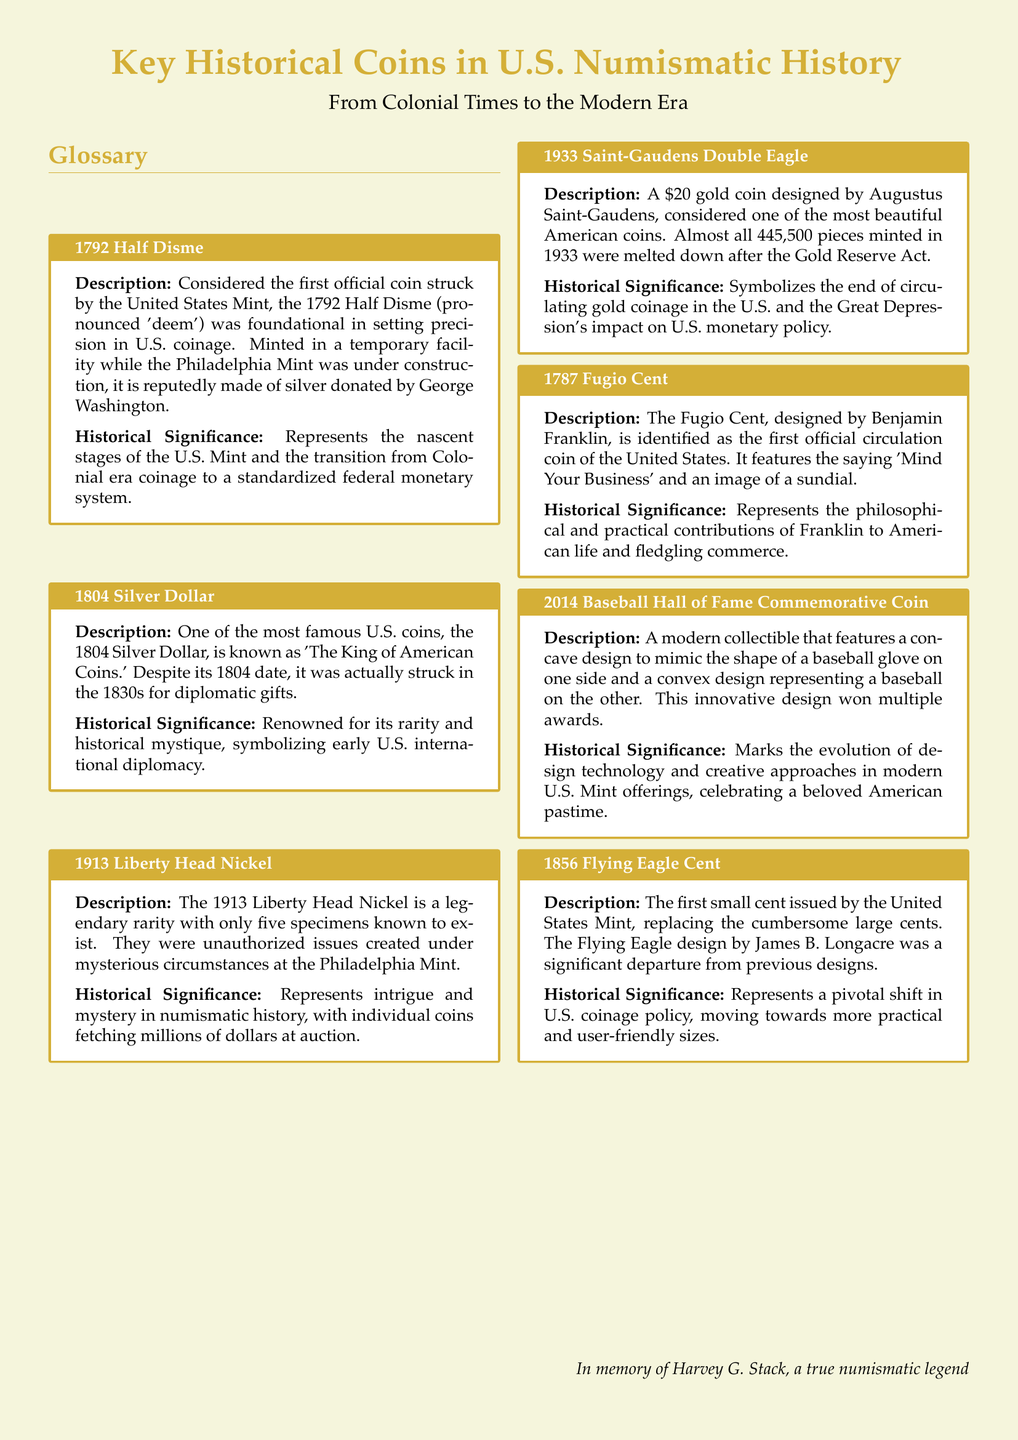What is the first official coin struck by the United States Mint? The document specifies the first official coin as the 1792 Half Disme.
Answer: 1792 Half Disme What year was the Silver Dollar that is known as 'The King of American Coins' minted? According to the document, the 1804 Silver Dollar has a mint date of 1804.
Answer: 1804 How many known specimens of the 1913 Liberty Head Nickel exist? The document mentions that there are only five specimens known to exist.
Answer: Five Who designed the 1933 Saint-Gaudens Double Eagle? The document states that it was designed by Augustus Saint-Gaudens.
Answer: Augustus Saint-Gaudens What is the significance of the saying 'Mind Your Business' on the Fugio Cent? The document indicates that it represents the philosophical contributions of Franklin.
Answer: Philosophical contributions What does the 2014 Baseball Hall of Fame Commemorative Coin celebrate? According to the document, it celebrates a beloved American pastime.
Answer: American pastime What was a major change represented by the 1856 Flying Eagle Cent? The document notes that it represents a shift towards more practical and user-friendly sizes.
Answer: Practical sizes Why was most of the 1933 Saint-Gaudens Double Eagle melted down? The document states it was melted down after the Gold Reserve Act.
Answer: Gold Reserve Act What innovative design feature does the 2014 Baseball Hall of Fame Commemorative Coin have? The document mentions it features a concave design to mimic a baseball glove.
Answer: Concave design 